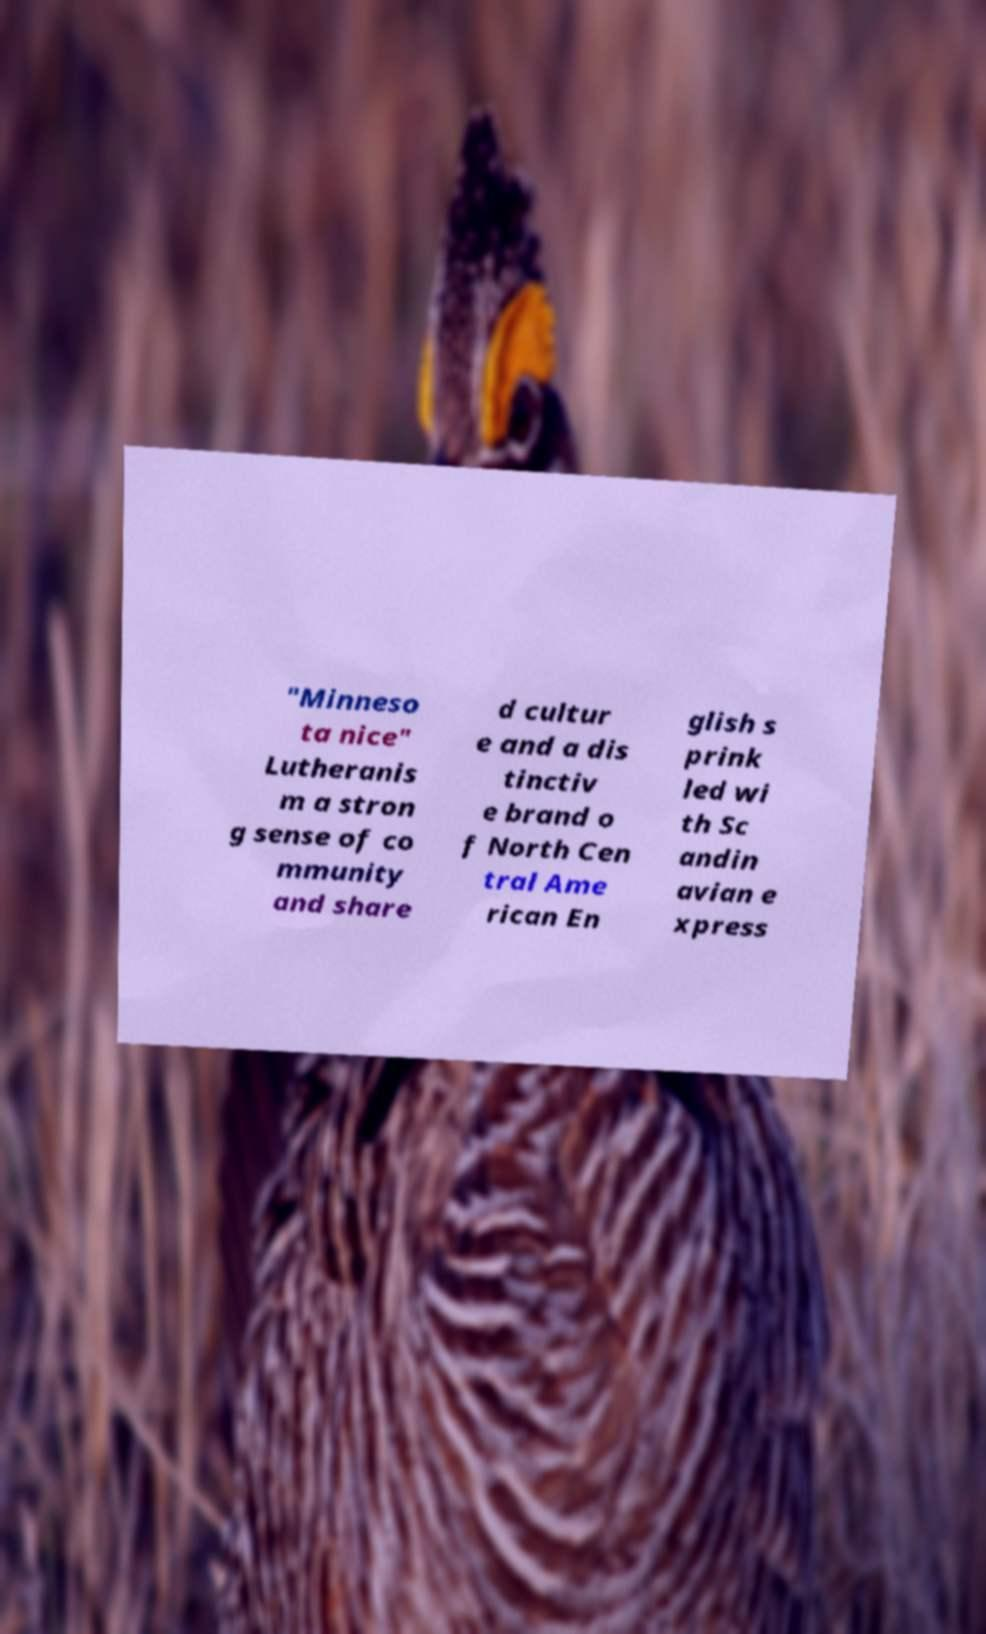For documentation purposes, I need the text within this image transcribed. Could you provide that? "Minneso ta nice" Lutheranis m a stron g sense of co mmunity and share d cultur e and a dis tinctiv e brand o f North Cen tral Ame rican En glish s prink led wi th Sc andin avian e xpress 